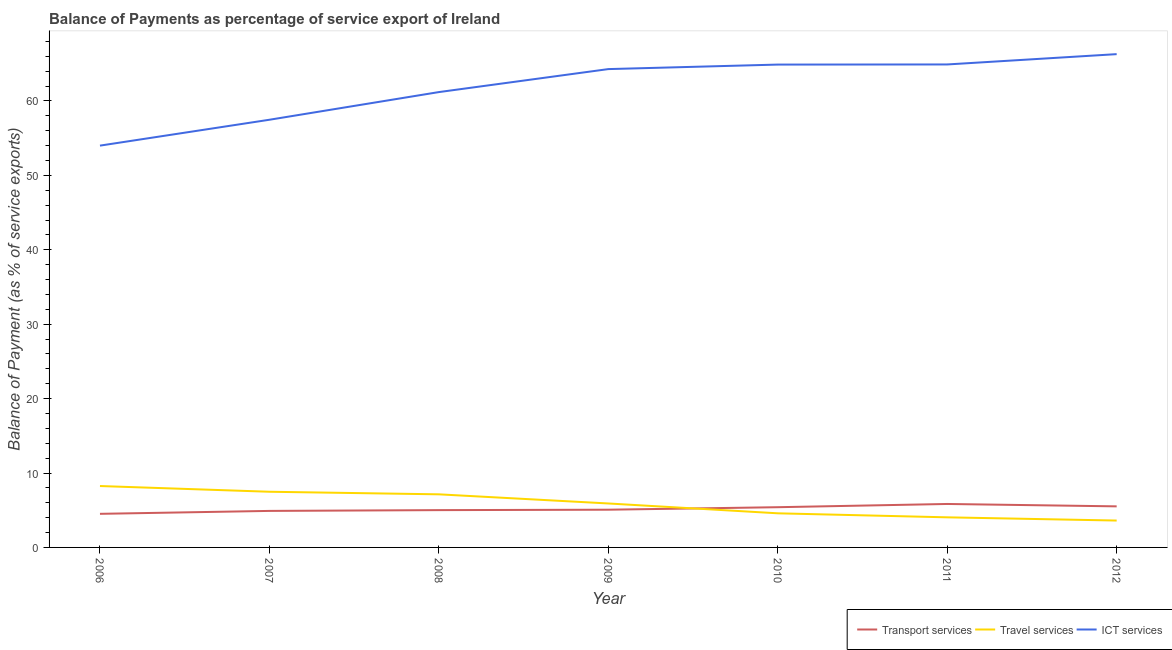Does the line corresponding to balance of payment of ict services intersect with the line corresponding to balance of payment of transport services?
Keep it short and to the point. No. What is the balance of payment of transport services in 2009?
Your answer should be very brief. 5.07. Across all years, what is the maximum balance of payment of ict services?
Make the answer very short. 66.3. Across all years, what is the minimum balance of payment of ict services?
Keep it short and to the point. 54. In which year was the balance of payment of travel services minimum?
Make the answer very short. 2012. What is the total balance of payment of travel services in the graph?
Your answer should be compact. 41.02. What is the difference between the balance of payment of transport services in 2011 and that in 2012?
Your answer should be very brief. 0.32. What is the difference between the balance of payment of travel services in 2010 and the balance of payment of ict services in 2006?
Keep it short and to the point. -49.42. What is the average balance of payment of transport services per year?
Make the answer very short. 5.18. In the year 2009, what is the difference between the balance of payment of ict services and balance of payment of travel services?
Offer a terse response. 58.38. What is the ratio of the balance of payment of travel services in 2009 to that in 2010?
Make the answer very short. 1.29. Is the difference between the balance of payment of travel services in 2010 and 2011 greater than the difference between the balance of payment of transport services in 2010 and 2011?
Provide a short and direct response. Yes. What is the difference between the highest and the second highest balance of payment of travel services?
Your response must be concise. 0.77. What is the difference between the highest and the lowest balance of payment of transport services?
Offer a terse response. 1.33. In how many years, is the balance of payment of transport services greater than the average balance of payment of transport services taken over all years?
Your answer should be compact. 3. Is the sum of the balance of payment of ict services in 2009 and 2010 greater than the maximum balance of payment of travel services across all years?
Provide a succinct answer. Yes. Does the balance of payment of transport services monotonically increase over the years?
Provide a succinct answer. No. Is the balance of payment of ict services strictly greater than the balance of payment of travel services over the years?
Give a very brief answer. Yes. Are the values on the major ticks of Y-axis written in scientific E-notation?
Offer a terse response. No. Does the graph contain any zero values?
Your answer should be very brief. No. Where does the legend appear in the graph?
Keep it short and to the point. Bottom right. What is the title of the graph?
Give a very brief answer. Balance of Payments as percentage of service export of Ireland. What is the label or title of the Y-axis?
Your response must be concise. Balance of Payment (as % of service exports). What is the Balance of Payment (as % of service exports) of Transport services in 2006?
Offer a terse response. 4.52. What is the Balance of Payment (as % of service exports) of Travel services in 2006?
Keep it short and to the point. 8.25. What is the Balance of Payment (as % of service exports) in ICT services in 2006?
Your response must be concise. 54. What is the Balance of Payment (as % of service exports) of Transport services in 2007?
Ensure brevity in your answer.  4.91. What is the Balance of Payment (as % of service exports) of Travel services in 2007?
Your answer should be very brief. 7.48. What is the Balance of Payment (as % of service exports) of ICT services in 2007?
Keep it short and to the point. 57.48. What is the Balance of Payment (as % of service exports) of Transport services in 2008?
Make the answer very short. 5.01. What is the Balance of Payment (as % of service exports) of Travel services in 2008?
Give a very brief answer. 7.14. What is the Balance of Payment (as % of service exports) in ICT services in 2008?
Offer a terse response. 61.2. What is the Balance of Payment (as % of service exports) of Transport services in 2009?
Keep it short and to the point. 5.07. What is the Balance of Payment (as % of service exports) of Travel services in 2009?
Ensure brevity in your answer.  5.91. What is the Balance of Payment (as % of service exports) in ICT services in 2009?
Provide a short and direct response. 64.29. What is the Balance of Payment (as % of service exports) of Transport services in 2010?
Offer a very short reply. 5.4. What is the Balance of Payment (as % of service exports) in Travel services in 2010?
Your answer should be very brief. 4.59. What is the Balance of Payment (as % of service exports) in ICT services in 2010?
Give a very brief answer. 64.89. What is the Balance of Payment (as % of service exports) of Transport services in 2011?
Give a very brief answer. 5.84. What is the Balance of Payment (as % of service exports) of Travel services in 2011?
Provide a succinct answer. 4.04. What is the Balance of Payment (as % of service exports) of ICT services in 2011?
Give a very brief answer. 64.91. What is the Balance of Payment (as % of service exports) of Transport services in 2012?
Your answer should be very brief. 5.52. What is the Balance of Payment (as % of service exports) in Travel services in 2012?
Ensure brevity in your answer.  3.61. What is the Balance of Payment (as % of service exports) in ICT services in 2012?
Make the answer very short. 66.3. Across all years, what is the maximum Balance of Payment (as % of service exports) in Transport services?
Offer a terse response. 5.84. Across all years, what is the maximum Balance of Payment (as % of service exports) in Travel services?
Your answer should be very brief. 8.25. Across all years, what is the maximum Balance of Payment (as % of service exports) of ICT services?
Your answer should be very brief. 66.3. Across all years, what is the minimum Balance of Payment (as % of service exports) in Transport services?
Your answer should be compact. 4.52. Across all years, what is the minimum Balance of Payment (as % of service exports) in Travel services?
Keep it short and to the point. 3.61. Across all years, what is the minimum Balance of Payment (as % of service exports) in ICT services?
Offer a terse response. 54. What is the total Balance of Payment (as % of service exports) in Transport services in the graph?
Your answer should be compact. 36.27. What is the total Balance of Payment (as % of service exports) in Travel services in the graph?
Your answer should be compact. 41.02. What is the total Balance of Payment (as % of service exports) of ICT services in the graph?
Make the answer very short. 433.06. What is the difference between the Balance of Payment (as % of service exports) in Transport services in 2006 and that in 2007?
Your answer should be compact. -0.39. What is the difference between the Balance of Payment (as % of service exports) of Travel services in 2006 and that in 2007?
Provide a short and direct response. 0.77. What is the difference between the Balance of Payment (as % of service exports) of ICT services in 2006 and that in 2007?
Your answer should be very brief. -3.48. What is the difference between the Balance of Payment (as % of service exports) in Transport services in 2006 and that in 2008?
Your answer should be compact. -0.5. What is the difference between the Balance of Payment (as % of service exports) in Travel services in 2006 and that in 2008?
Your response must be concise. 1.11. What is the difference between the Balance of Payment (as % of service exports) of ICT services in 2006 and that in 2008?
Keep it short and to the point. -7.2. What is the difference between the Balance of Payment (as % of service exports) of Transport services in 2006 and that in 2009?
Your answer should be compact. -0.56. What is the difference between the Balance of Payment (as % of service exports) of Travel services in 2006 and that in 2009?
Provide a short and direct response. 2.34. What is the difference between the Balance of Payment (as % of service exports) in ICT services in 2006 and that in 2009?
Your answer should be compact. -10.29. What is the difference between the Balance of Payment (as % of service exports) of Transport services in 2006 and that in 2010?
Keep it short and to the point. -0.89. What is the difference between the Balance of Payment (as % of service exports) of Travel services in 2006 and that in 2010?
Give a very brief answer. 3.67. What is the difference between the Balance of Payment (as % of service exports) in ICT services in 2006 and that in 2010?
Your answer should be very brief. -10.89. What is the difference between the Balance of Payment (as % of service exports) in Transport services in 2006 and that in 2011?
Provide a succinct answer. -1.33. What is the difference between the Balance of Payment (as % of service exports) in Travel services in 2006 and that in 2011?
Your answer should be very brief. 4.21. What is the difference between the Balance of Payment (as % of service exports) in ICT services in 2006 and that in 2011?
Offer a terse response. -10.91. What is the difference between the Balance of Payment (as % of service exports) of Transport services in 2006 and that in 2012?
Your response must be concise. -1. What is the difference between the Balance of Payment (as % of service exports) in Travel services in 2006 and that in 2012?
Provide a short and direct response. 4.64. What is the difference between the Balance of Payment (as % of service exports) of ICT services in 2006 and that in 2012?
Offer a terse response. -12.29. What is the difference between the Balance of Payment (as % of service exports) of Transport services in 2007 and that in 2008?
Offer a terse response. -0.1. What is the difference between the Balance of Payment (as % of service exports) of Travel services in 2007 and that in 2008?
Provide a short and direct response. 0.35. What is the difference between the Balance of Payment (as % of service exports) of ICT services in 2007 and that in 2008?
Your response must be concise. -3.72. What is the difference between the Balance of Payment (as % of service exports) in Transport services in 2007 and that in 2009?
Provide a short and direct response. -0.16. What is the difference between the Balance of Payment (as % of service exports) of Travel services in 2007 and that in 2009?
Your answer should be compact. 1.57. What is the difference between the Balance of Payment (as % of service exports) of ICT services in 2007 and that in 2009?
Give a very brief answer. -6.81. What is the difference between the Balance of Payment (as % of service exports) of Transport services in 2007 and that in 2010?
Ensure brevity in your answer.  -0.5. What is the difference between the Balance of Payment (as % of service exports) of Travel services in 2007 and that in 2010?
Ensure brevity in your answer.  2.9. What is the difference between the Balance of Payment (as % of service exports) of ICT services in 2007 and that in 2010?
Offer a terse response. -7.41. What is the difference between the Balance of Payment (as % of service exports) of Transport services in 2007 and that in 2011?
Your response must be concise. -0.93. What is the difference between the Balance of Payment (as % of service exports) in Travel services in 2007 and that in 2011?
Offer a terse response. 3.44. What is the difference between the Balance of Payment (as % of service exports) in ICT services in 2007 and that in 2011?
Your answer should be very brief. -7.43. What is the difference between the Balance of Payment (as % of service exports) in Transport services in 2007 and that in 2012?
Your answer should be very brief. -0.61. What is the difference between the Balance of Payment (as % of service exports) of Travel services in 2007 and that in 2012?
Offer a very short reply. 3.87. What is the difference between the Balance of Payment (as % of service exports) of ICT services in 2007 and that in 2012?
Provide a succinct answer. -8.82. What is the difference between the Balance of Payment (as % of service exports) in Transport services in 2008 and that in 2009?
Provide a short and direct response. -0.06. What is the difference between the Balance of Payment (as % of service exports) of Travel services in 2008 and that in 2009?
Ensure brevity in your answer.  1.23. What is the difference between the Balance of Payment (as % of service exports) in ICT services in 2008 and that in 2009?
Give a very brief answer. -3.09. What is the difference between the Balance of Payment (as % of service exports) of Transport services in 2008 and that in 2010?
Make the answer very short. -0.39. What is the difference between the Balance of Payment (as % of service exports) in Travel services in 2008 and that in 2010?
Offer a terse response. 2.55. What is the difference between the Balance of Payment (as % of service exports) in ICT services in 2008 and that in 2010?
Your response must be concise. -3.7. What is the difference between the Balance of Payment (as % of service exports) of Transport services in 2008 and that in 2011?
Your response must be concise. -0.83. What is the difference between the Balance of Payment (as % of service exports) in Travel services in 2008 and that in 2011?
Provide a short and direct response. 3.09. What is the difference between the Balance of Payment (as % of service exports) of ICT services in 2008 and that in 2011?
Offer a very short reply. -3.71. What is the difference between the Balance of Payment (as % of service exports) in Transport services in 2008 and that in 2012?
Ensure brevity in your answer.  -0.51. What is the difference between the Balance of Payment (as % of service exports) of Travel services in 2008 and that in 2012?
Give a very brief answer. 3.52. What is the difference between the Balance of Payment (as % of service exports) of ICT services in 2008 and that in 2012?
Make the answer very short. -5.1. What is the difference between the Balance of Payment (as % of service exports) of Transport services in 2009 and that in 2010?
Your answer should be compact. -0.33. What is the difference between the Balance of Payment (as % of service exports) of Travel services in 2009 and that in 2010?
Your answer should be very brief. 1.32. What is the difference between the Balance of Payment (as % of service exports) of ICT services in 2009 and that in 2010?
Offer a very short reply. -0.61. What is the difference between the Balance of Payment (as % of service exports) in Transport services in 2009 and that in 2011?
Offer a terse response. -0.77. What is the difference between the Balance of Payment (as % of service exports) of Travel services in 2009 and that in 2011?
Your answer should be compact. 1.86. What is the difference between the Balance of Payment (as % of service exports) in ICT services in 2009 and that in 2011?
Offer a terse response. -0.62. What is the difference between the Balance of Payment (as % of service exports) in Transport services in 2009 and that in 2012?
Provide a short and direct response. -0.45. What is the difference between the Balance of Payment (as % of service exports) of Travel services in 2009 and that in 2012?
Provide a succinct answer. 2.3. What is the difference between the Balance of Payment (as % of service exports) in ICT services in 2009 and that in 2012?
Offer a terse response. -2.01. What is the difference between the Balance of Payment (as % of service exports) of Transport services in 2010 and that in 2011?
Provide a succinct answer. -0.44. What is the difference between the Balance of Payment (as % of service exports) in Travel services in 2010 and that in 2011?
Your answer should be compact. 0.54. What is the difference between the Balance of Payment (as % of service exports) in ICT services in 2010 and that in 2011?
Make the answer very short. -0.02. What is the difference between the Balance of Payment (as % of service exports) of Transport services in 2010 and that in 2012?
Offer a terse response. -0.11. What is the difference between the Balance of Payment (as % of service exports) of Travel services in 2010 and that in 2012?
Give a very brief answer. 0.97. What is the difference between the Balance of Payment (as % of service exports) of ICT services in 2010 and that in 2012?
Your answer should be very brief. -1.4. What is the difference between the Balance of Payment (as % of service exports) of Transport services in 2011 and that in 2012?
Your answer should be very brief. 0.32. What is the difference between the Balance of Payment (as % of service exports) in Travel services in 2011 and that in 2012?
Provide a short and direct response. 0.43. What is the difference between the Balance of Payment (as % of service exports) of ICT services in 2011 and that in 2012?
Give a very brief answer. -1.38. What is the difference between the Balance of Payment (as % of service exports) of Transport services in 2006 and the Balance of Payment (as % of service exports) of Travel services in 2007?
Your answer should be compact. -2.97. What is the difference between the Balance of Payment (as % of service exports) in Transport services in 2006 and the Balance of Payment (as % of service exports) in ICT services in 2007?
Keep it short and to the point. -52.96. What is the difference between the Balance of Payment (as % of service exports) in Travel services in 2006 and the Balance of Payment (as % of service exports) in ICT services in 2007?
Your answer should be compact. -49.23. What is the difference between the Balance of Payment (as % of service exports) of Transport services in 2006 and the Balance of Payment (as % of service exports) of Travel services in 2008?
Your answer should be very brief. -2.62. What is the difference between the Balance of Payment (as % of service exports) of Transport services in 2006 and the Balance of Payment (as % of service exports) of ICT services in 2008?
Make the answer very short. -56.68. What is the difference between the Balance of Payment (as % of service exports) of Travel services in 2006 and the Balance of Payment (as % of service exports) of ICT services in 2008?
Offer a terse response. -52.94. What is the difference between the Balance of Payment (as % of service exports) in Transport services in 2006 and the Balance of Payment (as % of service exports) in Travel services in 2009?
Offer a terse response. -1.39. What is the difference between the Balance of Payment (as % of service exports) of Transport services in 2006 and the Balance of Payment (as % of service exports) of ICT services in 2009?
Make the answer very short. -59.77. What is the difference between the Balance of Payment (as % of service exports) of Travel services in 2006 and the Balance of Payment (as % of service exports) of ICT services in 2009?
Make the answer very short. -56.03. What is the difference between the Balance of Payment (as % of service exports) in Transport services in 2006 and the Balance of Payment (as % of service exports) in Travel services in 2010?
Your answer should be compact. -0.07. What is the difference between the Balance of Payment (as % of service exports) in Transport services in 2006 and the Balance of Payment (as % of service exports) in ICT services in 2010?
Make the answer very short. -60.38. What is the difference between the Balance of Payment (as % of service exports) in Travel services in 2006 and the Balance of Payment (as % of service exports) in ICT services in 2010?
Give a very brief answer. -56.64. What is the difference between the Balance of Payment (as % of service exports) in Transport services in 2006 and the Balance of Payment (as % of service exports) in Travel services in 2011?
Provide a succinct answer. 0.47. What is the difference between the Balance of Payment (as % of service exports) of Transport services in 2006 and the Balance of Payment (as % of service exports) of ICT services in 2011?
Offer a very short reply. -60.4. What is the difference between the Balance of Payment (as % of service exports) in Travel services in 2006 and the Balance of Payment (as % of service exports) in ICT services in 2011?
Keep it short and to the point. -56.66. What is the difference between the Balance of Payment (as % of service exports) of Transport services in 2006 and the Balance of Payment (as % of service exports) of Travel services in 2012?
Give a very brief answer. 0.9. What is the difference between the Balance of Payment (as % of service exports) of Transport services in 2006 and the Balance of Payment (as % of service exports) of ICT services in 2012?
Make the answer very short. -61.78. What is the difference between the Balance of Payment (as % of service exports) of Travel services in 2006 and the Balance of Payment (as % of service exports) of ICT services in 2012?
Make the answer very short. -58.04. What is the difference between the Balance of Payment (as % of service exports) in Transport services in 2007 and the Balance of Payment (as % of service exports) in Travel services in 2008?
Provide a short and direct response. -2.23. What is the difference between the Balance of Payment (as % of service exports) in Transport services in 2007 and the Balance of Payment (as % of service exports) in ICT services in 2008?
Provide a short and direct response. -56.29. What is the difference between the Balance of Payment (as % of service exports) of Travel services in 2007 and the Balance of Payment (as % of service exports) of ICT services in 2008?
Make the answer very short. -53.71. What is the difference between the Balance of Payment (as % of service exports) of Transport services in 2007 and the Balance of Payment (as % of service exports) of Travel services in 2009?
Offer a terse response. -1. What is the difference between the Balance of Payment (as % of service exports) of Transport services in 2007 and the Balance of Payment (as % of service exports) of ICT services in 2009?
Give a very brief answer. -59.38. What is the difference between the Balance of Payment (as % of service exports) of Travel services in 2007 and the Balance of Payment (as % of service exports) of ICT services in 2009?
Provide a short and direct response. -56.8. What is the difference between the Balance of Payment (as % of service exports) in Transport services in 2007 and the Balance of Payment (as % of service exports) in Travel services in 2010?
Provide a short and direct response. 0.32. What is the difference between the Balance of Payment (as % of service exports) of Transport services in 2007 and the Balance of Payment (as % of service exports) of ICT services in 2010?
Your response must be concise. -59.98. What is the difference between the Balance of Payment (as % of service exports) in Travel services in 2007 and the Balance of Payment (as % of service exports) in ICT services in 2010?
Ensure brevity in your answer.  -57.41. What is the difference between the Balance of Payment (as % of service exports) of Transport services in 2007 and the Balance of Payment (as % of service exports) of Travel services in 2011?
Make the answer very short. 0.86. What is the difference between the Balance of Payment (as % of service exports) of Transport services in 2007 and the Balance of Payment (as % of service exports) of ICT services in 2011?
Provide a short and direct response. -60. What is the difference between the Balance of Payment (as % of service exports) in Travel services in 2007 and the Balance of Payment (as % of service exports) in ICT services in 2011?
Provide a short and direct response. -57.43. What is the difference between the Balance of Payment (as % of service exports) of Transport services in 2007 and the Balance of Payment (as % of service exports) of Travel services in 2012?
Offer a very short reply. 1.3. What is the difference between the Balance of Payment (as % of service exports) of Transport services in 2007 and the Balance of Payment (as % of service exports) of ICT services in 2012?
Offer a very short reply. -61.39. What is the difference between the Balance of Payment (as % of service exports) in Travel services in 2007 and the Balance of Payment (as % of service exports) in ICT services in 2012?
Make the answer very short. -58.81. What is the difference between the Balance of Payment (as % of service exports) in Transport services in 2008 and the Balance of Payment (as % of service exports) in Travel services in 2009?
Offer a very short reply. -0.9. What is the difference between the Balance of Payment (as % of service exports) of Transport services in 2008 and the Balance of Payment (as % of service exports) of ICT services in 2009?
Offer a very short reply. -59.27. What is the difference between the Balance of Payment (as % of service exports) of Travel services in 2008 and the Balance of Payment (as % of service exports) of ICT services in 2009?
Keep it short and to the point. -57.15. What is the difference between the Balance of Payment (as % of service exports) of Transport services in 2008 and the Balance of Payment (as % of service exports) of Travel services in 2010?
Provide a short and direct response. 0.43. What is the difference between the Balance of Payment (as % of service exports) in Transport services in 2008 and the Balance of Payment (as % of service exports) in ICT services in 2010?
Offer a very short reply. -59.88. What is the difference between the Balance of Payment (as % of service exports) in Travel services in 2008 and the Balance of Payment (as % of service exports) in ICT services in 2010?
Keep it short and to the point. -57.76. What is the difference between the Balance of Payment (as % of service exports) in Transport services in 2008 and the Balance of Payment (as % of service exports) in Travel services in 2011?
Ensure brevity in your answer.  0.97. What is the difference between the Balance of Payment (as % of service exports) of Transport services in 2008 and the Balance of Payment (as % of service exports) of ICT services in 2011?
Ensure brevity in your answer.  -59.9. What is the difference between the Balance of Payment (as % of service exports) of Travel services in 2008 and the Balance of Payment (as % of service exports) of ICT services in 2011?
Make the answer very short. -57.77. What is the difference between the Balance of Payment (as % of service exports) in Transport services in 2008 and the Balance of Payment (as % of service exports) in Travel services in 2012?
Provide a short and direct response. 1.4. What is the difference between the Balance of Payment (as % of service exports) of Transport services in 2008 and the Balance of Payment (as % of service exports) of ICT services in 2012?
Provide a short and direct response. -61.28. What is the difference between the Balance of Payment (as % of service exports) of Travel services in 2008 and the Balance of Payment (as % of service exports) of ICT services in 2012?
Give a very brief answer. -59.16. What is the difference between the Balance of Payment (as % of service exports) of Transport services in 2009 and the Balance of Payment (as % of service exports) of Travel services in 2010?
Your answer should be compact. 0.48. What is the difference between the Balance of Payment (as % of service exports) of Transport services in 2009 and the Balance of Payment (as % of service exports) of ICT services in 2010?
Your answer should be compact. -59.82. What is the difference between the Balance of Payment (as % of service exports) in Travel services in 2009 and the Balance of Payment (as % of service exports) in ICT services in 2010?
Provide a short and direct response. -58.98. What is the difference between the Balance of Payment (as % of service exports) in Transport services in 2009 and the Balance of Payment (as % of service exports) in Travel services in 2011?
Your answer should be compact. 1.03. What is the difference between the Balance of Payment (as % of service exports) of Transport services in 2009 and the Balance of Payment (as % of service exports) of ICT services in 2011?
Offer a terse response. -59.84. What is the difference between the Balance of Payment (as % of service exports) of Travel services in 2009 and the Balance of Payment (as % of service exports) of ICT services in 2011?
Your answer should be compact. -59. What is the difference between the Balance of Payment (as % of service exports) of Transport services in 2009 and the Balance of Payment (as % of service exports) of Travel services in 2012?
Provide a short and direct response. 1.46. What is the difference between the Balance of Payment (as % of service exports) in Transport services in 2009 and the Balance of Payment (as % of service exports) in ICT services in 2012?
Offer a terse response. -61.22. What is the difference between the Balance of Payment (as % of service exports) of Travel services in 2009 and the Balance of Payment (as % of service exports) of ICT services in 2012?
Your answer should be very brief. -60.39. What is the difference between the Balance of Payment (as % of service exports) of Transport services in 2010 and the Balance of Payment (as % of service exports) of Travel services in 2011?
Give a very brief answer. 1.36. What is the difference between the Balance of Payment (as % of service exports) of Transport services in 2010 and the Balance of Payment (as % of service exports) of ICT services in 2011?
Ensure brevity in your answer.  -59.51. What is the difference between the Balance of Payment (as % of service exports) in Travel services in 2010 and the Balance of Payment (as % of service exports) in ICT services in 2011?
Provide a short and direct response. -60.32. What is the difference between the Balance of Payment (as % of service exports) in Transport services in 2010 and the Balance of Payment (as % of service exports) in Travel services in 2012?
Offer a very short reply. 1.79. What is the difference between the Balance of Payment (as % of service exports) of Transport services in 2010 and the Balance of Payment (as % of service exports) of ICT services in 2012?
Provide a succinct answer. -60.89. What is the difference between the Balance of Payment (as % of service exports) of Travel services in 2010 and the Balance of Payment (as % of service exports) of ICT services in 2012?
Provide a short and direct response. -61.71. What is the difference between the Balance of Payment (as % of service exports) in Transport services in 2011 and the Balance of Payment (as % of service exports) in Travel services in 2012?
Keep it short and to the point. 2.23. What is the difference between the Balance of Payment (as % of service exports) in Transport services in 2011 and the Balance of Payment (as % of service exports) in ICT services in 2012?
Your answer should be compact. -60.45. What is the difference between the Balance of Payment (as % of service exports) in Travel services in 2011 and the Balance of Payment (as % of service exports) in ICT services in 2012?
Your response must be concise. -62.25. What is the average Balance of Payment (as % of service exports) in Transport services per year?
Make the answer very short. 5.18. What is the average Balance of Payment (as % of service exports) in Travel services per year?
Provide a short and direct response. 5.86. What is the average Balance of Payment (as % of service exports) of ICT services per year?
Provide a short and direct response. 61.87. In the year 2006, what is the difference between the Balance of Payment (as % of service exports) of Transport services and Balance of Payment (as % of service exports) of Travel services?
Make the answer very short. -3.74. In the year 2006, what is the difference between the Balance of Payment (as % of service exports) of Transport services and Balance of Payment (as % of service exports) of ICT services?
Your answer should be compact. -49.49. In the year 2006, what is the difference between the Balance of Payment (as % of service exports) of Travel services and Balance of Payment (as % of service exports) of ICT services?
Keep it short and to the point. -45.75. In the year 2007, what is the difference between the Balance of Payment (as % of service exports) of Transport services and Balance of Payment (as % of service exports) of Travel services?
Offer a terse response. -2.57. In the year 2007, what is the difference between the Balance of Payment (as % of service exports) in Transport services and Balance of Payment (as % of service exports) in ICT services?
Give a very brief answer. -52.57. In the year 2007, what is the difference between the Balance of Payment (as % of service exports) in Travel services and Balance of Payment (as % of service exports) in ICT services?
Offer a terse response. -50. In the year 2008, what is the difference between the Balance of Payment (as % of service exports) of Transport services and Balance of Payment (as % of service exports) of Travel services?
Make the answer very short. -2.12. In the year 2008, what is the difference between the Balance of Payment (as % of service exports) of Transport services and Balance of Payment (as % of service exports) of ICT services?
Your answer should be compact. -56.18. In the year 2008, what is the difference between the Balance of Payment (as % of service exports) in Travel services and Balance of Payment (as % of service exports) in ICT services?
Offer a very short reply. -54.06. In the year 2009, what is the difference between the Balance of Payment (as % of service exports) of Transport services and Balance of Payment (as % of service exports) of Travel services?
Your answer should be very brief. -0.84. In the year 2009, what is the difference between the Balance of Payment (as % of service exports) in Transport services and Balance of Payment (as % of service exports) in ICT services?
Offer a terse response. -59.22. In the year 2009, what is the difference between the Balance of Payment (as % of service exports) in Travel services and Balance of Payment (as % of service exports) in ICT services?
Provide a succinct answer. -58.38. In the year 2010, what is the difference between the Balance of Payment (as % of service exports) in Transport services and Balance of Payment (as % of service exports) in Travel services?
Keep it short and to the point. 0.82. In the year 2010, what is the difference between the Balance of Payment (as % of service exports) of Transport services and Balance of Payment (as % of service exports) of ICT services?
Keep it short and to the point. -59.49. In the year 2010, what is the difference between the Balance of Payment (as % of service exports) in Travel services and Balance of Payment (as % of service exports) in ICT services?
Offer a terse response. -60.31. In the year 2011, what is the difference between the Balance of Payment (as % of service exports) of Transport services and Balance of Payment (as % of service exports) of Travel services?
Provide a short and direct response. 1.8. In the year 2011, what is the difference between the Balance of Payment (as % of service exports) of Transport services and Balance of Payment (as % of service exports) of ICT services?
Provide a short and direct response. -59.07. In the year 2011, what is the difference between the Balance of Payment (as % of service exports) in Travel services and Balance of Payment (as % of service exports) in ICT services?
Offer a terse response. -60.87. In the year 2012, what is the difference between the Balance of Payment (as % of service exports) in Transport services and Balance of Payment (as % of service exports) in Travel services?
Ensure brevity in your answer.  1.91. In the year 2012, what is the difference between the Balance of Payment (as % of service exports) of Transport services and Balance of Payment (as % of service exports) of ICT services?
Offer a very short reply. -60.78. In the year 2012, what is the difference between the Balance of Payment (as % of service exports) in Travel services and Balance of Payment (as % of service exports) in ICT services?
Make the answer very short. -62.68. What is the ratio of the Balance of Payment (as % of service exports) of Transport services in 2006 to that in 2007?
Provide a short and direct response. 0.92. What is the ratio of the Balance of Payment (as % of service exports) of Travel services in 2006 to that in 2007?
Keep it short and to the point. 1.1. What is the ratio of the Balance of Payment (as % of service exports) in ICT services in 2006 to that in 2007?
Make the answer very short. 0.94. What is the ratio of the Balance of Payment (as % of service exports) in Transport services in 2006 to that in 2008?
Offer a very short reply. 0.9. What is the ratio of the Balance of Payment (as % of service exports) of Travel services in 2006 to that in 2008?
Your response must be concise. 1.16. What is the ratio of the Balance of Payment (as % of service exports) of ICT services in 2006 to that in 2008?
Make the answer very short. 0.88. What is the ratio of the Balance of Payment (as % of service exports) in Transport services in 2006 to that in 2009?
Make the answer very short. 0.89. What is the ratio of the Balance of Payment (as % of service exports) of Travel services in 2006 to that in 2009?
Ensure brevity in your answer.  1.4. What is the ratio of the Balance of Payment (as % of service exports) in ICT services in 2006 to that in 2009?
Provide a succinct answer. 0.84. What is the ratio of the Balance of Payment (as % of service exports) of Transport services in 2006 to that in 2010?
Provide a short and direct response. 0.84. What is the ratio of the Balance of Payment (as % of service exports) in Travel services in 2006 to that in 2010?
Ensure brevity in your answer.  1.8. What is the ratio of the Balance of Payment (as % of service exports) in ICT services in 2006 to that in 2010?
Make the answer very short. 0.83. What is the ratio of the Balance of Payment (as % of service exports) of Transport services in 2006 to that in 2011?
Make the answer very short. 0.77. What is the ratio of the Balance of Payment (as % of service exports) of Travel services in 2006 to that in 2011?
Your answer should be very brief. 2.04. What is the ratio of the Balance of Payment (as % of service exports) of ICT services in 2006 to that in 2011?
Keep it short and to the point. 0.83. What is the ratio of the Balance of Payment (as % of service exports) of Transport services in 2006 to that in 2012?
Make the answer very short. 0.82. What is the ratio of the Balance of Payment (as % of service exports) in Travel services in 2006 to that in 2012?
Make the answer very short. 2.28. What is the ratio of the Balance of Payment (as % of service exports) in ICT services in 2006 to that in 2012?
Make the answer very short. 0.81. What is the ratio of the Balance of Payment (as % of service exports) in Transport services in 2007 to that in 2008?
Give a very brief answer. 0.98. What is the ratio of the Balance of Payment (as % of service exports) of Travel services in 2007 to that in 2008?
Give a very brief answer. 1.05. What is the ratio of the Balance of Payment (as % of service exports) of ICT services in 2007 to that in 2008?
Your answer should be very brief. 0.94. What is the ratio of the Balance of Payment (as % of service exports) of Travel services in 2007 to that in 2009?
Your answer should be compact. 1.27. What is the ratio of the Balance of Payment (as % of service exports) in ICT services in 2007 to that in 2009?
Your response must be concise. 0.89. What is the ratio of the Balance of Payment (as % of service exports) in Transport services in 2007 to that in 2010?
Make the answer very short. 0.91. What is the ratio of the Balance of Payment (as % of service exports) of Travel services in 2007 to that in 2010?
Make the answer very short. 1.63. What is the ratio of the Balance of Payment (as % of service exports) in ICT services in 2007 to that in 2010?
Offer a very short reply. 0.89. What is the ratio of the Balance of Payment (as % of service exports) of Transport services in 2007 to that in 2011?
Offer a terse response. 0.84. What is the ratio of the Balance of Payment (as % of service exports) in Travel services in 2007 to that in 2011?
Provide a short and direct response. 1.85. What is the ratio of the Balance of Payment (as % of service exports) of ICT services in 2007 to that in 2011?
Provide a short and direct response. 0.89. What is the ratio of the Balance of Payment (as % of service exports) of Transport services in 2007 to that in 2012?
Keep it short and to the point. 0.89. What is the ratio of the Balance of Payment (as % of service exports) of Travel services in 2007 to that in 2012?
Give a very brief answer. 2.07. What is the ratio of the Balance of Payment (as % of service exports) of ICT services in 2007 to that in 2012?
Your answer should be compact. 0.87. What is the ratio of the Balance of Payment (as % of service exports) of Transport services in 2008 to that in 2009?
Give a very brief answer. 0.99. What is the ratio of the Balance of Payment (as % of service exports) of Travel services in 2008 to that in 2009?
Your answer should be very brief. 1.21. What is the ratio of the Balance of Payment (as % of service exports) in ICT services in 2008 to that in 2009?
Your answer should be very brief. 0.95. What is the ratio of the Balance of Payment (as % of service exports) in Transport services in 2008 to that in 2010?
Give a very brief answer. 0.93. What is the ratio of the Balance of Payment (as % of service exports) in Travel services in 2008 to that in 2010?
Ensure brevity in your answer.  1.56. What is the ratio of the Balance of Payment (as % of service exports) in ICT services in 2008 to that in 2010?
Give a very brief answer. 0.94. What is the ratio of the Balance of Payment (as % of service exports) of Transport services in 2008 to that in 2011?
Provide a short and direct response. 0.86. What is the ratio of the Balance of Payment (as % of service exports) in Travel services in 2008 to that in 2011?
Your answer should be compact. 1.76. What is the ratio of the Balance of Payment (as % of service exports) in ICT services in 2008 to that in 2011?
Your answer should be compact. 0.94. What is the ratio of the Balance of Payment (as % of service exports) of Transport services in 2008 to that in 2012?
Give a very brief answer. 0.91. What is the ratio of the Balance of Payment (as % of service exports) in Travel services in 2008 to that in 2012?
Ensure brevity in your answer.  1.98. What is the ratio of the Balance of Payment (as % of service exports) in Transport services in 2009 to that in 2010?
Give a very brief answer. 0.94. What is the ratio of the Balance of Payment (as % of service exports) in Travel services in 2009 to that in 2010?
Keep it short and to the point. 1.29. What is the ratio of the Balance of Payment (as % of service exports) of ICT services in 2009 to that in 2010?
Your answer should be compact. 0.99. What is the ratio of the Balance of Payment (as % of service exports) in Transport services in 2009 to that in 2011?
Your answer should be compact. 0.87. What is the ratio of the Balance of Payment (as % of service exports) of Travel services in 2009 to that in 2011?
Offer a terse response. 1.46. What is the ratio of the Balance of Payment (as % of service exports) of ICT services in 2009 to that in 2011?
Provide a short and direct response. 0.99. What is the ratio of the Balance of Payment (as % of service exports) in Transport services in 2009 to that in 2012?
Your response must be concise. 0.92. What is the ratio of the Balance of Payment (as % of service exports) in Travel services in 2009 to that in 2012?
Offer a very short reply. 1.64. What is the ratio of the Balance of Payment (as % of service exports) of ICT services in 2009 to that in 2012?
Make the answer very short. 0.97. What is the ratio of the Balance of Payment (as % of service exports) in Transport services in 2010 to that in 2011?
Ensure brevity in your answer.  0.93. What is the ratio of the Balance of Payment (as % of service exports) in Travel services in 2010 to that in 2011?
Provide a succinct answer. 1.13. What is the ratio of the Balance of Payment (as % of service exports) of ICT services in 2010 to that in 2011?
Make the answer very short. 1. What is the ratio of the Balance of Payment (as % of service exports) in Transport services in 2010 to that in 2012?
Provide a short and direct response. 0.98. What is the ratio of the Balance of Payment (as % of service exports) in Travel services in 2010 to that in 2012?
Your answer should be very brief. 1.27. What is the ratio of the Balance of Payment (as % of service exports) of ICT services in 2010 to that in 2012?
Your answer should be very brief. 0.98. What is the ratio of the Balance of Payment (as % of service exports) in Transport services in 2011 to that in 2012?
Your answer should be very brief. 1.06. What is the ratio of the Balance of Payment (as % of service exports) of Travel services in 2011 to that in 2012?
Your answer should be compact. 1.12. What is the ratio of the Balance of Payment (as % of service exports) in ICT services in 2011 to that in 2012?
Your answer should be very brief. 0.98. What is the difference between the highest and the second highest Balance of Payment (as % of service exports) of Transport services?
Provide a succinct answer. 0.32. What is the difference between the highest and the second highest Balance of Payment (as % of service exports) of Travel services?
Your answer should be compact. 0.77. What is the difference between the highest and the second highest Balance of Payment (as % of service exports) in ICT services?
Your answer should be very brief. 1.38. What is the difference between the highest and the lowest Balance of Payment (as % of service exports) of Transport services?
Your answer should be compact. 1.33. What is the difference between the highest and the lowest Balance of Payment (as % of service exports) of Travel services?
Provide a short and direct response. 4.64. What is the difference between the highest and the lowest Balance of Payment (as % of service exports) in ICT services?
Offer a terse response. 12.29. 